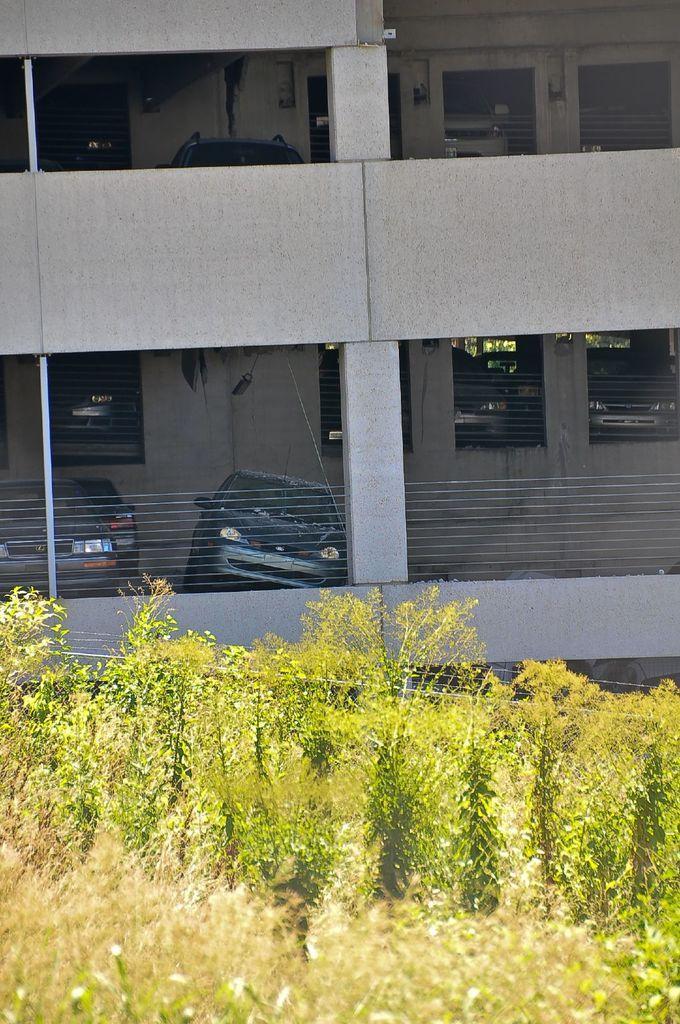Please provide a concise description of this image. In this picture I can observe some plants on the land. In the background there is a building. There are some cars parked in the parking lot. 